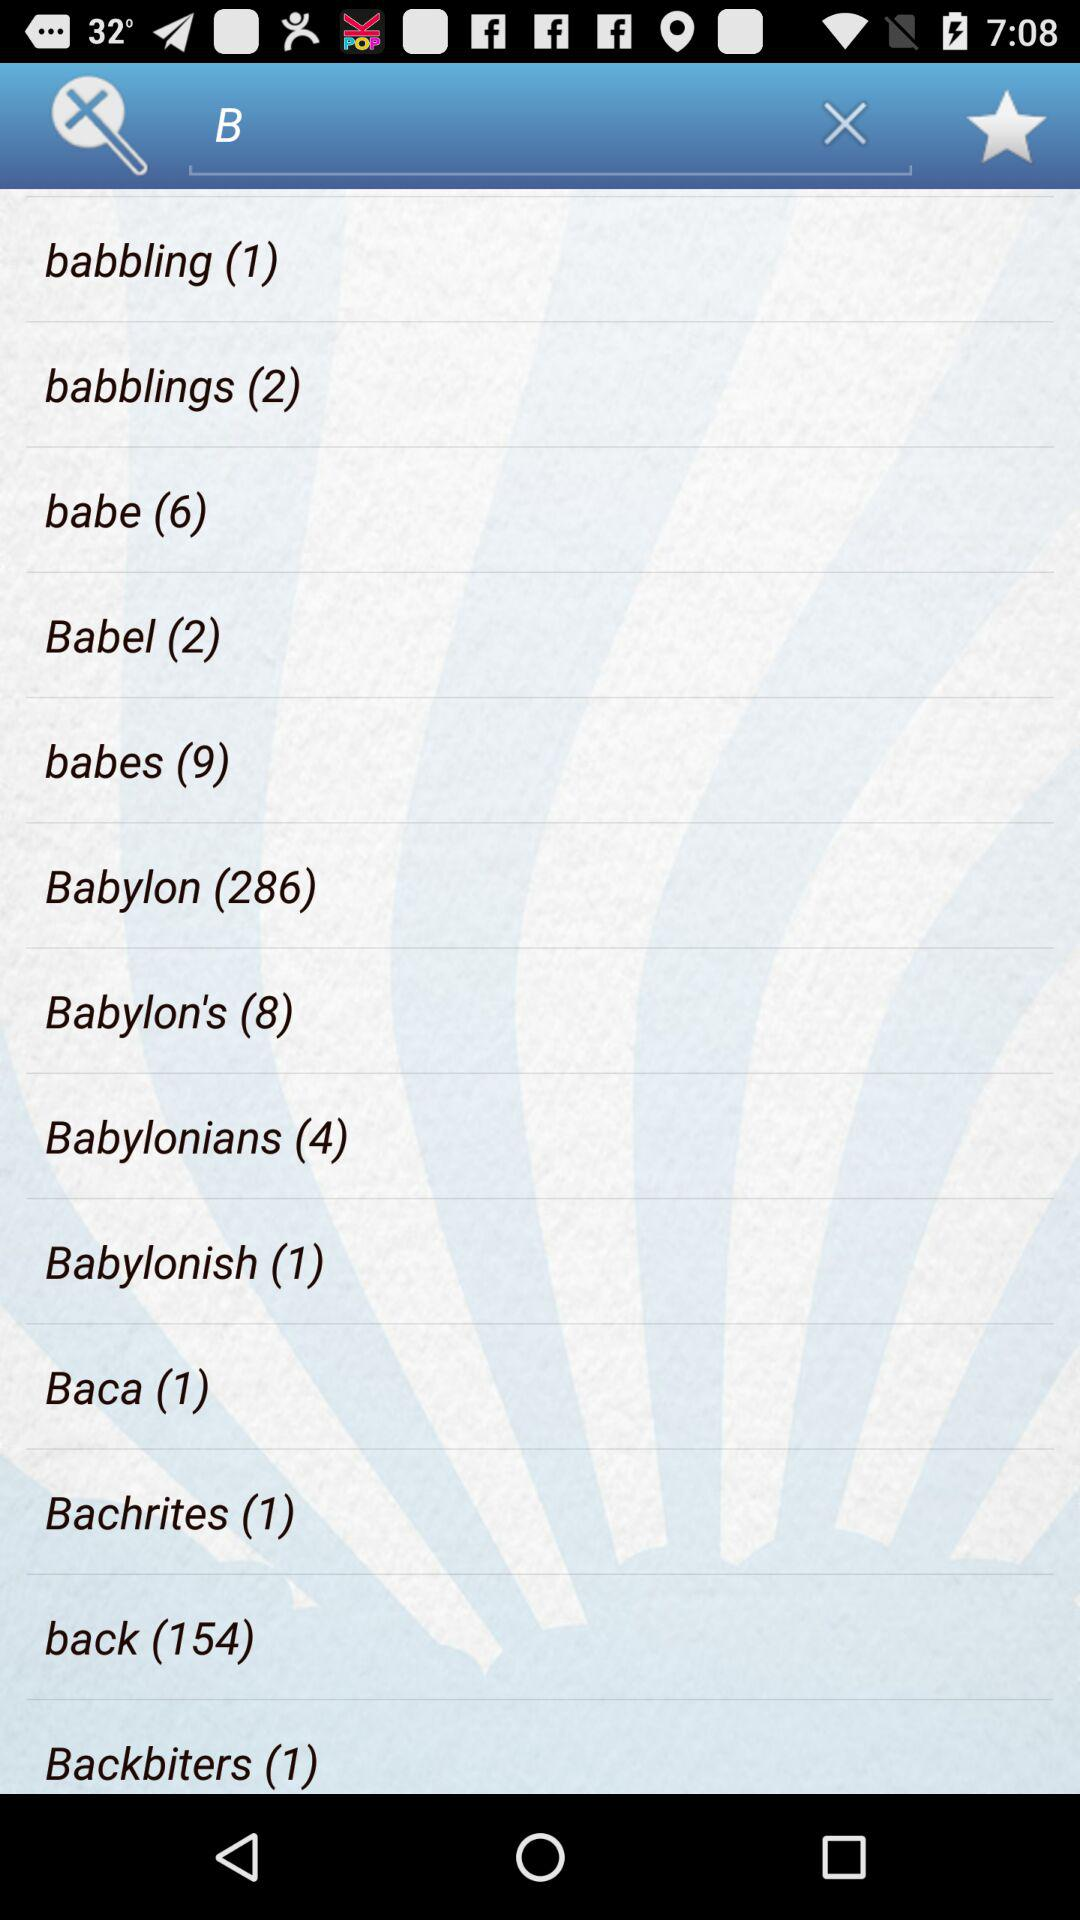How many items are there in "Baca"? There is 1 item in "Baca". 